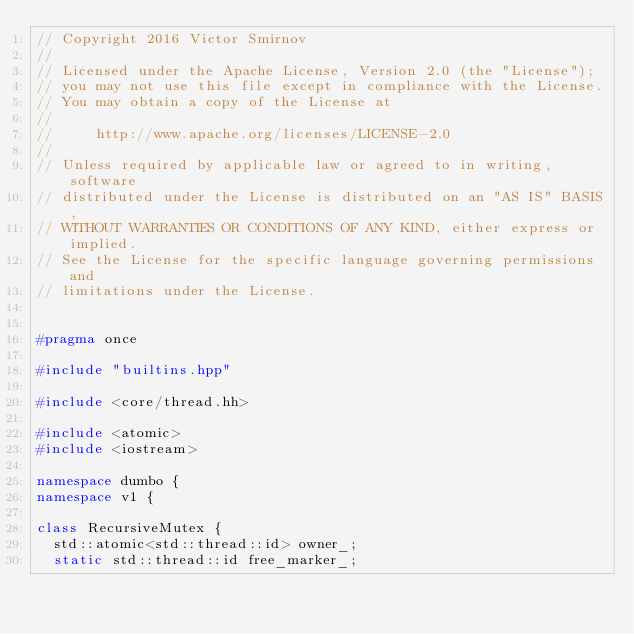Convert code to text. <code><loc_0><loc_0><loc_500><loc_500><_C++_>// Copyright 2016 Victor Smirnov
//
// Licensed under the Apache License, Version 2.0 (the "License");
// you may not use this file except in compliance with the License.
// You may obtain a copy of the License at
//
//     http://www.apache.org/licenses/LICENSE-2.0
//
// Unless required by applicable law or agreed to in writing, software
// distributed under the License is distributed on an "AS IS" BASIS,
// WITHOUT WARRANTIES OR CONDITIONS OF ANY KIND, either express or implied.
// See the License for the specific language governing permissions and
// limitations under the License.


#pragma once

#include "builtins.hpp"

#include <core/thread.hh>

#include <atomic>
#include <iostream>

namespace dumbo {
namespace v1 {

class RecursiveMutex {
	std::atomic<std::thread::id> owner_;
	static std::thread::id free_marker_;
</code> 